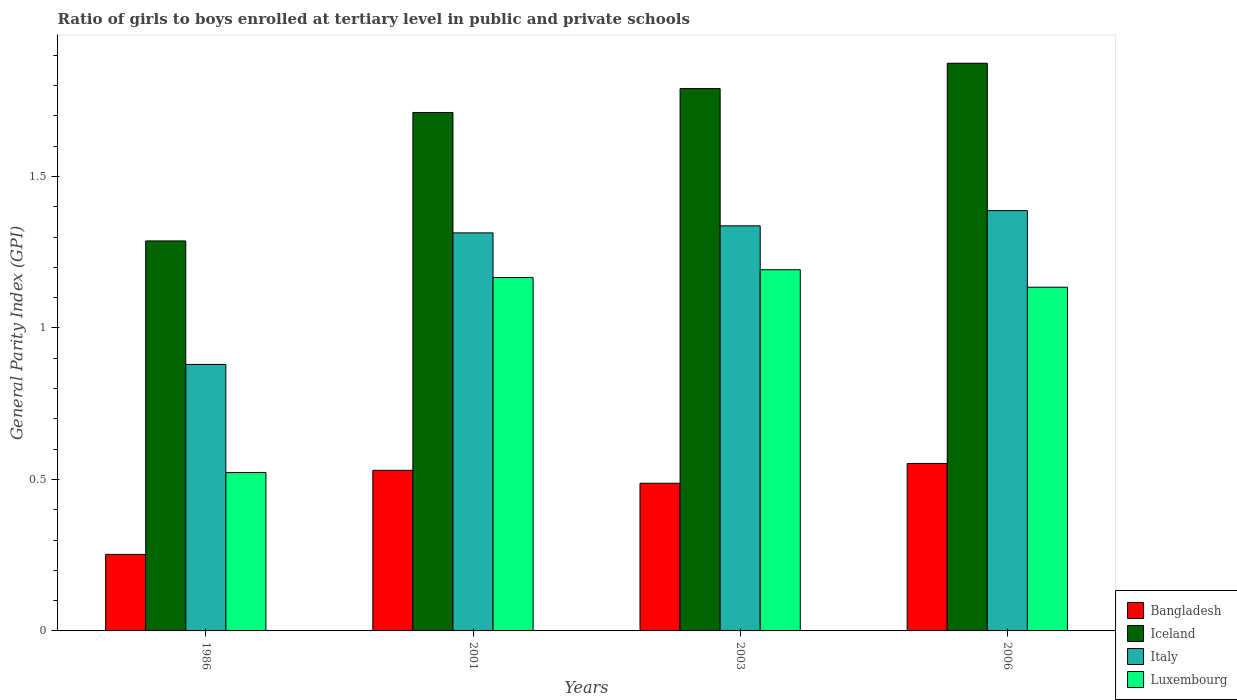How many different coloured bars are there?
Your answer should be very brief. 4. How many groups of bars are there?
Make the answer very short. 4. Are the number of bars per tick equal to the number of legend labels?
Keep it short and to the point. Yes. Are the number of bars on each tick of the X-axis equal?
Offer a very short reply. Yes. How many bars are there on the 3rd tick from the left?
Your answer should be compact. 4. What is the general parity index in Luxembourg in 2003?
Give a very brief answer. 1.19. Across all years, what is the maximum general parity index in Bangladesh?
Make the answer very short. 0.55. Across all years, what is the minimum general parity index in Bangladesh?
Provide a short and direct response. 0.25. In which year was the general parity index in Bangladesh maximum?
Your answer should be compact. 2006. In which year was the general parity index in Luxembourg minimum?
Provide a short and direct response. 1986. What is the total general parity index in Luxembourg in the graph?
Keep it short and to the point. 4.02. What is the difference between the general parity index in Bangladesh in 1986 and that in 2001?
Offer a very short reply. -0.28. What is the difference between the general parity index in Italy in 2001 and the general parity index in Iceland in 2006?
Provide a succinct answer. -0.56. What is the average general parity index in Luxembourg per year?
Make the answer very short. 1. In the year 2001, what is the difference between the general parity index in Bangladesh and general parity index in Luxembourg?
Your answer should be compact. -0.64. In how many years, is the general parity index in Bangladesh greater than 0.4?
Give a very brief answer. 3. What is the ratio of the general parity index in Italy in 2003 to that in 2006?
Your response must be concise. 0.96. Is the general parity index in Iceland in 2001 less than that in 2006?
Give a very brief answer. Yes. What is the difference between the highest and the second highest general parity index in Italy?
Give a very brief answer. 0.05. What is the difference between the highest and the lowest general parity index in Bangladesh?
Ensure brevity in your answer.  0.3. In how many years, is the general parity index in Bangladesh greater than the average general parity index in Bangladesh taken over all years?
Your response must be concise. 3. What does the 3rd bar from the left in 1986 represents?
Your answer should be compact. Italy. What does the 1st bar from the right in 2006 represents?
Offer a terse response. Luxembourg. How many bars are there?
Provide a succinct answer. 16. Are all the bars in the graph horizontal?
Your answer should be very brief. No. How many years are there in the graph?
Your answer should be compact. 4. What is the difference between two consecutive major ticks on the Y-axis?
Your answer should be very brief. 0.5. Are the values on the major ticks of Y-axis written in scientific E-notation?
Ensure brevity in your answer.  No. What is the title of the graph?
Give a very brief answer. Ratio of girls to boys enrolled at tertiary level in public and private schools. What is the label or title of the Y-axis?
Provide a short and direct response. General Parity Index (GPI). What is the General Parity Index (GPI) of Bangladesh in 1986?
Your answer should be compact. 0.25. What is the General Parity Index (GPI) of Iceland in 1986?
Offer a terse response. 1.29. What is the General Parity Index (GPI) in Italy in 1986?
Ensure brevity in your answer.  0.88. What is the General Parity Index (GPI) in Luxembourg in 1986?
Your response must be concise. 0.52. What is the General Parity Index (GPI) in Bangladesh in 2001?
Your answer should be compact. 0.53. What is the General Parity Index (GPI) of Iceland in 2001?
Your answer should be compact. 1.71. What is the General Parity Index (GPI) of Italy in 2001?
Ensure brevity in your answer.  1.31. What is the General Parity Index (GPI) in Luxembourg in 2001?
Keep it short and to the point. 1.17. What is the General Parity Index (GPI) of Bangladesh in 2003?
Provide a short and direct response. 0.49. What is the General Parity Index (GPI) in Iceland in 2003?
Make the answer very short. 1.79. What is the General Parity Index (GPI) in Italy in 2003?
Give a very brief answer. 1.34. What is the General Parity Index (GPI) of Luxembourg in 2003?
Your answer should be compact. 1.19. What is the General Parity Index (GPI) of Bangladesh in 2006?
Your answer should be very brief. 0.55. What is the General Parity Index (GPI) in Iceland in 2006?
Ensure brevity in your answer.  1.87. What is the General Parity Index (GPI) of Italy in 2006?
Make the answer very short. 1.39. What is the General Parity Index (GPI) in Luxembourg in 2006?
Offer a very short reply. 1.13. Across all years, what is the maximum General Parity Index (GPI) in Bangladesh?
Ensure brevity in your answer.  0.55. Across all years, what is the maximum General Parity Index (GPI) of Iceland?
Ensure brevity in your answer.  1.87. Across all years, what is the maximum General Parity Index (GPI) of Italy?
Provide a succinct answer. 1.39. Across all years, what is the maximum General Parity Index (GPI) in Luxembourg?
Make the answer very short. 1.19. Across all years, what is the minimum General Parity Index (GPI) in Bangladesh?
Ensure brevity in your answer.  0.25. Across all years, what is the minimum General Parity Index (GPI) in Iceland?
Offer a very short reply. 1.29. Across all years, what is the minimum General Parity Index (GPI) in Italy?
Offer a terse response. 0.88. Across all years, what is the minimum General Parity Index (GPI) of Luxembourg?
Offer a terse response. 0.52. What is the total General Parity Index (GPI) in Bangladesh in the graph?
Make the answer very short. 1.82. What is the total General Parity Index (GPI) of Iceland in the graph?
Keep it short and to the point. 6.66. What is the total General Parity Index (GPI) of Italy in the graph?
Offer a terse response. 4.92. What is the total General Parity Index (GPI) of Luxembourg in the graph?
Offer a very short reply. 4.02. What is the difference between the General Parity Index (GPI) of Bangladesh in 1986 and that in 2001?
Ensure brevity in your answer.  -0.28. What is the difference between the General Parity Index (GPI) of Iceland in 1986 and that in 2001?
Offer a terse response. -0.42. What is the difference between the General Parity Index (GPI) in Italy in 1986 and that in 2001?
Offer a very short reply. -0.43. What is the difference between the General Parity Index (GPI) in Luxembourg in 1986 and that in 2001?
Ensure brevity in your answer.  -0.64. What is the difference between the General Parity Index (GPI) of Bangladesh in 1986 and that in 2003?
Ensure brevity in your answer.  -0.23. What is the difference between the General Parity Index (GPI) of Iceland in 1986 and that in 2003?
Provide a succinct answer. -0.5. What is the difference between the General Parity Index (GPI) in Italy in 1986 and that in 2003?
Your answer should be very brief. -0.46. What is the difference between the General Parity Index (GPI) of Luxembourg in 1986 and that in 2003?
Your answer should be compact. -0.67. What is the difference between the General Parity Index (GPI) in Bangladesh in 1986 and that in 2006?
Make the answer very short. -0.3. What is the difference between the General Parity Index (GPI) of Iceland in 1986 and that in 2006?
Your answer should be very brief. -0.59. What is the difference between the General Parity Index (GPI) of Italy in 1986 and that in 2006?
Your answer should be very brief. -0.51. What is the difference between the General Parity Index (GPI) of Luxembourg in 1986 and that in 2006?
Your response must be concise. -0.61. What is the difference between the General Parity Index (GPI) of Bangladesh in 2001 and that in 2003?
Provide a short and direct response. 0.04. What is the difference between the General Parity Index (GPI) in Iceland in 2001 and that in 2003?
Your answer should be very brief. -0.08. What is the difference between the General Parity Index (GPI) in Italy in 2001 and that in 2003?
Provide a short and direct response. -0.02. What is the difference between the General Parity Index (GPI) in Luxembourg in 2001 and that in 2003?
Offer a very short reply. -0.03. What is the difference between the General Parity Index (GPI) of Bangladesh in 2001 and that in 2006?
Offer a terse response. -0.02. What is the difference between the General Parity Index (GPI) of Iceland in 2001 and that in 2006?
Offer a very short reply. -0.16. What is the difference between the General Parity Index (GPI) in Italy in 2001 and that in 2006?
Offer a very short reply. -0.07. What is the difference between the General Parity Index (GPI) of Luxembourg in 2001 and that in 2006?
Give a very brief answer. 0.03. What is the difference between the General Parity Index (GPI) in Bangladesh in 2003 and that in 2006?
Provide a short and direct response. -0.07. What is the difference between the General Parity Index (GPI) in Iceland in 2003 and that in 2006?
Ensure brevity in your answer.  -0.08. What is the difference between the General Parity Index (GPI) of Italy in 2003 and that in 2006?
Your answer should be compact. -0.05. What is the difference between the General Parity Index (GPI) of Luxembourg in 2003 and that in 2006?
Provide a succinct answer. 0.06. What is the difference between the General Parity Index (GPI) of Bangladesh in 1986 and the General Parity Index (GPI) of Iceland in 2001?
Give a very brief answer. -1.46. What is the difference between the General Parity Index (GPI) in Bangladesh in 1986 and the General Parity Index (GPI) in Italy in 2001?
Your response must be concise. -1.06. What is the difference between the General Parity Index (GPI) of Bangladesh in 1986 and the General Parity Index (GPI) of Luxembourg in 2001?
Keep it short and to the point. -0.91. What is the difference between the General Parity Index (GPI) in Iceland in 1986 and the General Parity Index (GPI) in Italy in 2001?
Your response must be concise. -0.03. What is the difference between the General Parity Index (GPI) of Iceland in 1986 and the General Parity Index (GPI) of Luxembourg in 2001?
Your response must be concise. 0.12. What is the difference between the General Parity Index (GPI) in Italy in 1986 and the General Parity Index (GPI) in Luxembourg in 2001?
Offer a terse response. -0.29. What is the difference between the General Parity Index (GPI) of Bangladesh in 1986 and the General Parity Index (GPI) of Iceland in 2003?
Your response must be concise. -1.54. What is the difference between the General Parity Index (GPI) in Bangladesh in 1986 and the General Parity Index (GPI) in Italy in 2003?
Keep it short and to the point. -1.08. What is the difference between the General Parity Index (GPI) in Bangladesh in 1986 and the General Parity Index (GPI) in Luxembourg in 2003?
Your answer should be very brief. -0.94. What is the difference between the General Parity Index (GPI) of Iceland in 1986 and the General Parity Index (GPI) of Italy in 2003?
Offer a very short reply. -0.05. What is the difference between the General Parity Index (GPI) in Iceland in 1986 and the General Parity Index (GPI) in Luxembourg in 2003?
Ensure brevity in your answer.  0.1. What is the difference between the General Parity Index (GPI) in Italy in 1986 and the General Parity Index (GPI) in Luxembourg in 2003?
Give a very brief answer. -0.31. What is the difference between the General Parity Index (GPI) of Bangladesh in 1986 and the General Parity Index (GPI) of Iceland in 2006?
Ensure brevity in your answer.  -1.62. What is the difference between the General Parity Index (GPI) of Bangladesh in 1986 and the General Parity Index (GPI) of Italy in 2006?
Give a very brief answer. -1.13. What is the difference between the General Parity Index (GPI) in Bangladesh in 1986 and the General Parity Index (GPI) in Luxembourg in 2006?
Ensure brevity in your answer.  -0.88. What is the difference between the General Parity Index (GPI) of Iceland in 1986 and the General Parity Index (GPI) of Luxembourg in 2006?
Your answer should be very brief. 0.15. What is the difference between the General Parity Index (GPI) in Italy in 1986 and the General Parity Index (GPI) in Luxembourg in 2006?
Make the answer very short. -0.25. What is the difference between the General Parity Index (GPI) of Bangladesh in 2001 and the General Parity Index (GPI) of Iceland in 2003?
Your response must be concise. -1.26. What is the difference between the General Parity Index (GPI) of Bangladesh in 2001 and the General Parity Index (GPI) of Italy in 2003?
Make the answer very short. -0.81. What is the difference between the General Parity Index (GPI) in Bangladesh in 2001 and the General Parity Index (GPI) in Luxembourg in 2003?
Your answer should be very brief. -0.66. What is the difference between the General Parity Index (GPI) of Iceland in 2001 and the General Parity Index (GPI) of Italy in 2003?
Offer a terse response. 0.37. What is the difference between the General Parity Index (GPI) in Iceland in 2001 and the General Parity Index (GPI) in Luxembourg in 2003?
Ensure brevity in your answer.  0.52. What is the difference between the General Parity Index (GPI) in Italy in 2001 and the General Parity Index (GPI) in Luxembourg in 2003?
Ensure brevity in your answer.  0.12. What is the difference between the General Parity Index (GPI) of Bangladesh in 2001 and the General Parity Index (GPI) of Iceland in 2006?
Ensure brevity in your answer.  -1.34. What is the difference between the General Parity Index (GPI) in Bangladesh in 2001 and the General Parity Index (GPI) in Italy in 2006?
Ensure brevity in your answer.  -0.86. What is the difference between the General Parity Index (GPI) in Bangladesh in 2001 and the General Parity Index (GPI) in Luxembourg in 2006?
Offer a terse response. -0.6. What is the difference between the General Parity Index (GPI) in Iceland in 2001 and the General Parity Index (GPI) in Italy in 2006?
Ensure brevity in your answer.  0.32. What is the difference between the General Parity Index (GPI) in Iceland in 2001 and the General Parity Index (GPI) in Luxembourg in 2006?
Your response must be concise. 0.58. What is the difference between the General Parity Index (GPI) of Italy in 2001 and the General Parity Index (GPI) of Luxembourg in 2006?
Provide a succinct answer. 0.18. What is the difference between the General Parity Index (GPI) in Bangladesh in 2003 and the General Parity Index (GPI) in Iceland in 2006?
Your answer should be compact. -1.39. What is the difference between the General Parity Index (GPI) in Bangladesh in 2003 and the General Parity Index (GPI) in Italy in 2006?
Your answer should be compact. -0.9. What is the difference between the General Parity Index (GPI) of Bangladesh in 2003 and the General Parity Index (GPI) of Luxembourg in 2006?
Provide a succinct answer. -0.65. What is the difference between the General Parity Index (GPI) of Iceland in 2003 and the General Parity Index (GPI) of Italy in 2006?
Offer a terse response. 0.4. What is the difference between the General Parity Index (GPI) in Iceland in 2003 and the General Parity Index (GPI) in Luxembourg in 2006?
Ensure brevity in your answer.  0.66. What is the difference between the General Parity Index (GPI) of Italy in 2003 and the General Parity Index (GPI) of Luxembourg in 2006?
Keep it short and to the point. 0.2. What is the average General Parity Index (GPI) of Bangladesh per year?
Make the answer very short. 0.46. What is the average General Parity Index (GPI) in Iceland per year?
Your answer should be very brief. 1.67. What is the average General Parity Index (GPI) in Italy per year?
Ensure brevity in your answer.  1.23. In the year 1986, what is the difference between the General Parity Index (GPI) in Bangladesh and General Parity Index (GPI) in Iceland?
Ensure brevity in your answer.  -1.03. In the year 1986, what is the difference between the General Parity Index (GPI) of Bangladesh and General Parity Index (GPI) of Italy?
Your answer should be compact. -0.63. In the year 1986, what is the difference between the General Parity Index (GPI) of Bangladesh and General Parity Index (GPI) of Luxembourg?
Provide a succinct answer. -0.27. In the year 1986, what is the difference between the General Parity Index (GPI) in Iceland and General Parity Index (GPI) in Italy?
Provide a short and direct response. 0.41. In the year 1986, what is the difference between the General Parity Index (GPI) of Iceland and General Parity Index (GPI) of Luxembourg?
Your response must be concise. 0.76. In the year 1986, what is the difference between the General Parity Index (GPI) of Italy and General Parity Index (GPI) of Luxembourg?
Give a very brief answer. 0.36. In the year 2001, what is the difference between the General Parity Index (GPI) in Bangladesh and General Parity Index (GPI) in Iceland?
Keep it short and to the point. -1.18. In the year 2001, what is the difference between the General Parity Index (GPI) in Bangladesh and General Parity Index (GPI) in Italy?
Give a very brief answer. -0.78. In the year 2001, what is the difference between the General Parity Index (GPI) in Bangladesh and General Parity Index (GPI) in Luxembourg?
Your answer should be compact. -0.64. In the year 2001, what is the difference between the General Parity Index (GPI) in Iceland and General Parity Index (GPI) in Italy?
Make the answer very short. 0.4. In the year 2001, what is the difference between the General Parity Index (GPI) of Iceland and General Parity Index (GPI) of Luxembourg?
Your answer should be compact. 0.54. In the year 2001, what is the difference between the General Parity Index (GPI) in Italy and General Parity Index (GPI) in Luxembourg?
Make the answer very short. 0.15. In the year 2003, what is the difference between the General Parity Index (GPI) in Bangladesh and General Parity Index (GPI) in Iceland?
Ensure brevity in your answer.  -1.3. In the year 2003, what is the difference between the General Parity Index (GPI) of Bangladesh and General Parity Index (GPI) of Italy?
Make the answer very short. -0.85. In the year 2003, what is the difference between the General Parity Index (GPI) in Bangladesh and General Parity Index (GPI) in Luxembourg?
Give a very brief answer. -0.7. In the year 2003, what is the difference between the General Parity Index (GPI) in Iceland and General Parity Index (GPI) in Italy?
Offer a terse response. 0.45. In the year 2003, what is the difference between the General Parity Index (GPI) of Iceland and General Parity Index (GPI) of Luxembourg?
Ensure brevity in your answer.  0.6. In the year 2003, what is the difference between the General Parity Index (GPI) of Italy and General Parity Index (GPI) of Luxembourg?
Ensure brevity in your answer.  0.14. In the year 2006, what is the difference between the General Parity Index (GPI) of Bangladesh and General Parity Index (GPI) of Iceland?
Your answer should be very brief. -1.32. In the year 2006, what is the difference between the General Parity Index (GPI) of Bangladesh and General Parity Index (GPI) of Italy?
Give a very brief answer. -0.83. In the year 2006, what is the difference between the General Parity Index (GPI) in Bangladesh and General Parity Index (GPI) in Luxembourg?
Your response must be concise. -0.58. In the year 2006, what is the difference between the General Parity Index (GPI) of Iceland and General Parity Index (GPI) of Italy?
Offer a very short reply. 0.49. In the year 2006, what is the difference between the General Parity Index (GPI) of Iceland and General Parity Index (GPI) of Luxembourg?
Your answer should be very brief. 0.74. In the year 2006, what is the difference between the General Parity Index (GPI) in Italy and General Parity Index (GPI) in Luxembourg?
Make the answer very short. 0.25. What is the ratio of the General Parity Index (GPI) in Bangladesh in 1986 to that in 2001?
Provide a short and direct response. 0.48. What is the ratio of the General Parity Index (GPI) of Iceland in 1986 to that in 2001?
Offer a terse response. 0.75. What is the ratio of the General Parity Index (GPI) in Italy in 1986 to that in 2001?
Your answer should be very brief. 0.67. What is the ratio of the General Parity Index (GPI) of Luxembourg in 1986 to that in 2001?
Ensure brevity in your answer.  0.45. What is the ratio of the General Parity Index (GPI) of Bangladesh in 1986 to that in 2003?
Give a very brief answer. 0.52. What is the ratio of the General Parity Index (GPI) of Iceland in 1986 to that in 2003?
Your answer should be compact. 0.72. What is the ratio of the General Parity Index (GPI) of Italy in 1986 to that in 2003?
Keep it short and to the point. 0.66. What is the ratio of the General Parity Index (GPI) in Luxembourg in 1986 to that in 2003?
Your answer should be very brief. 0.44. What is the ratio of the General Parity Index (GPI) in Bangladesh in 1986 to that in 2006?
Your response must be concise. 0.46. What is the ratio of the General Parity Index (GPI) of Iceland in 1986 to that in 2006?
Provide a succinct answer. 0.69. What is the ratio of the General Parity Index (GPI) in Italy in 1986 to that in 2006?
Ensure brevity in your answer.  0.63. What is the ratio of the General Parity Index (GPI) in Luxembourg in 1986 to that in 2006?
Keep it short and to the point. 0.46. What is the ratio of the General Parity Index (GPI) of Bangladesh in 2001 to that in 2003?
Your response must be concise. 1.09. What is the ratio of the General Parity Index (GPI) of Iceland in 2001 to that in 2003?
Offer a very short reply. 0.96. What is the ratio of the General Parity Index (GPI) in Italy in 2001 to that in 2003?
Your answer should be very brief. 0.98. What is the ratio of the General Parity Index (GPI) in Luxembourg in 2001 to that in 2003?
Ensure brevity in your answer.  0.98. What is the ratio of the General Parity Index (GPI) of Bangladesh in 2001 to that in 2006?
Offer a very short reply. 0.96. What is the ratio of the General Parity Index (GPI) in Iceland in 2001 to that in 2006?
Keep it short and to the point. 0.91. What is the ratio of the General Parity Index (GPI) of Italy in 2001 to that in 2006?
Offer a very short reply. 0.95. What is the ratio of the General Parity Index (GPI) in Luxembourg in 2001 to that in 2006?
Provide a succinct answer. 1.03. What is the ratio of the General Parity Index (GPI) in Bangladesh in 2003 to that in 2006?
Provide a succinct answer. 0.88. What is the ratio of the General Parity Index (GPI) of Iceland in 2003 to that in 2006?
Your answer should be very brief. 0.96. What is the ratio of the General Parity Index (GPI) in Italy in 2003 to that in 2006?
Provide a short and direct response. 0.96. What is the ratio of the General Parity Index (GPI) in Luxembourg in 2003 to that in 2006?
Offer a very short reply. 1.05. What is the difference between the highest and the second highest General Parity Index (GPI) of Bangladesh?
Provide a short and direct response. 0.02. What is the difference between the highest and the second highest General Parity Index (GPI) in Iceland?
Give a very brief answer. 0.08. What is the difference between the highest and the second highest General Parity Index (GPI) of Italy?
Make the answer very short. 0.05. What is the difference between the highest and the second highest General Parity Index (GPI) of Luxembourg?
Provide a short and direct response. 0.03. What is the difference between the highest and the lowest General Parity Index (GPI) of Bangladesh?
Your answer should be compact. 0.3. What is the difference between the highest and the lowest General Parity Index (GPI) in Iceland?
Give a very brief answer. 0.59. What is the difference between the highest and the lowest General Parity Index (GPI) in Italy?
Your answer should be compact. 0.51. What is the difference between the highest and the lowest General Parity Index (GPI) in Luxembourg?
Your answer should be very brief. 0.67. 